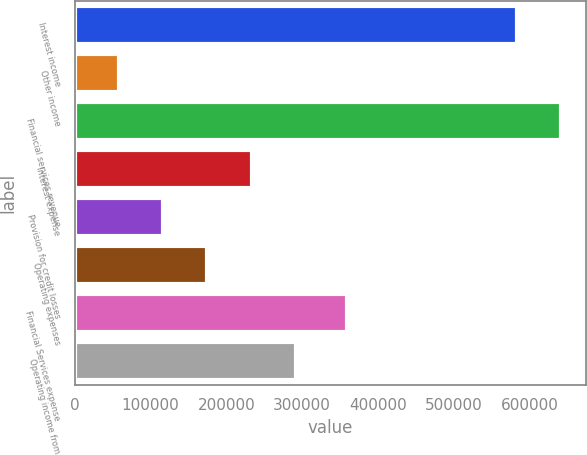Convert chart. <chart><loc_0><loc_0><loc_500><loc_500><bar_chart><fcel>Interest income<fcel>Other income<fcel>Financial services revenue<fcel>Interest expense<fcel>Provision for credit losses<fcel>Operating expenses<fcel>Financial Services expense<fcel>Operating income from<nl><fcel>583174<fcel>58408<fcel>641582<fcel>233360<fcel>116725<fcel>175043<fcel>358489<fcel>291678<nl></chart> 